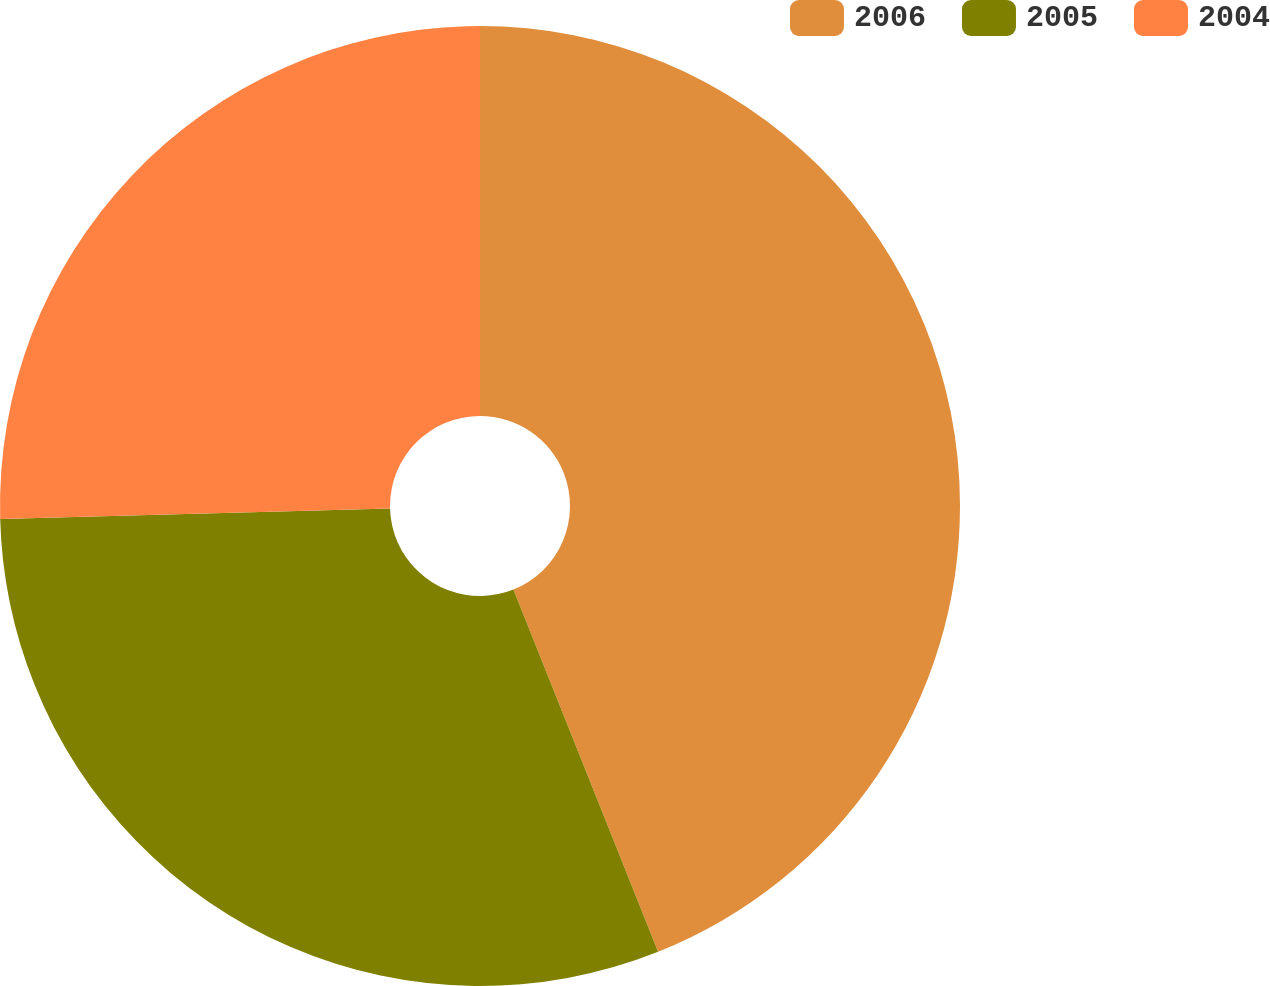<chart> <loc_0><loc_0><loc_500><loc_500><pie_chart><fcel>2006<fcel>2005<fcel>2004<nl><fcel>43.95%<fcel>30.62%<fcel>25.43%<nl></chart> 